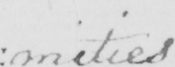Can you tell me what this handwritten text says? : mities 